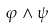<formula> <loc_0><loc_0><loc_500><loc_500>\varphi \wedge \psi</formula> 